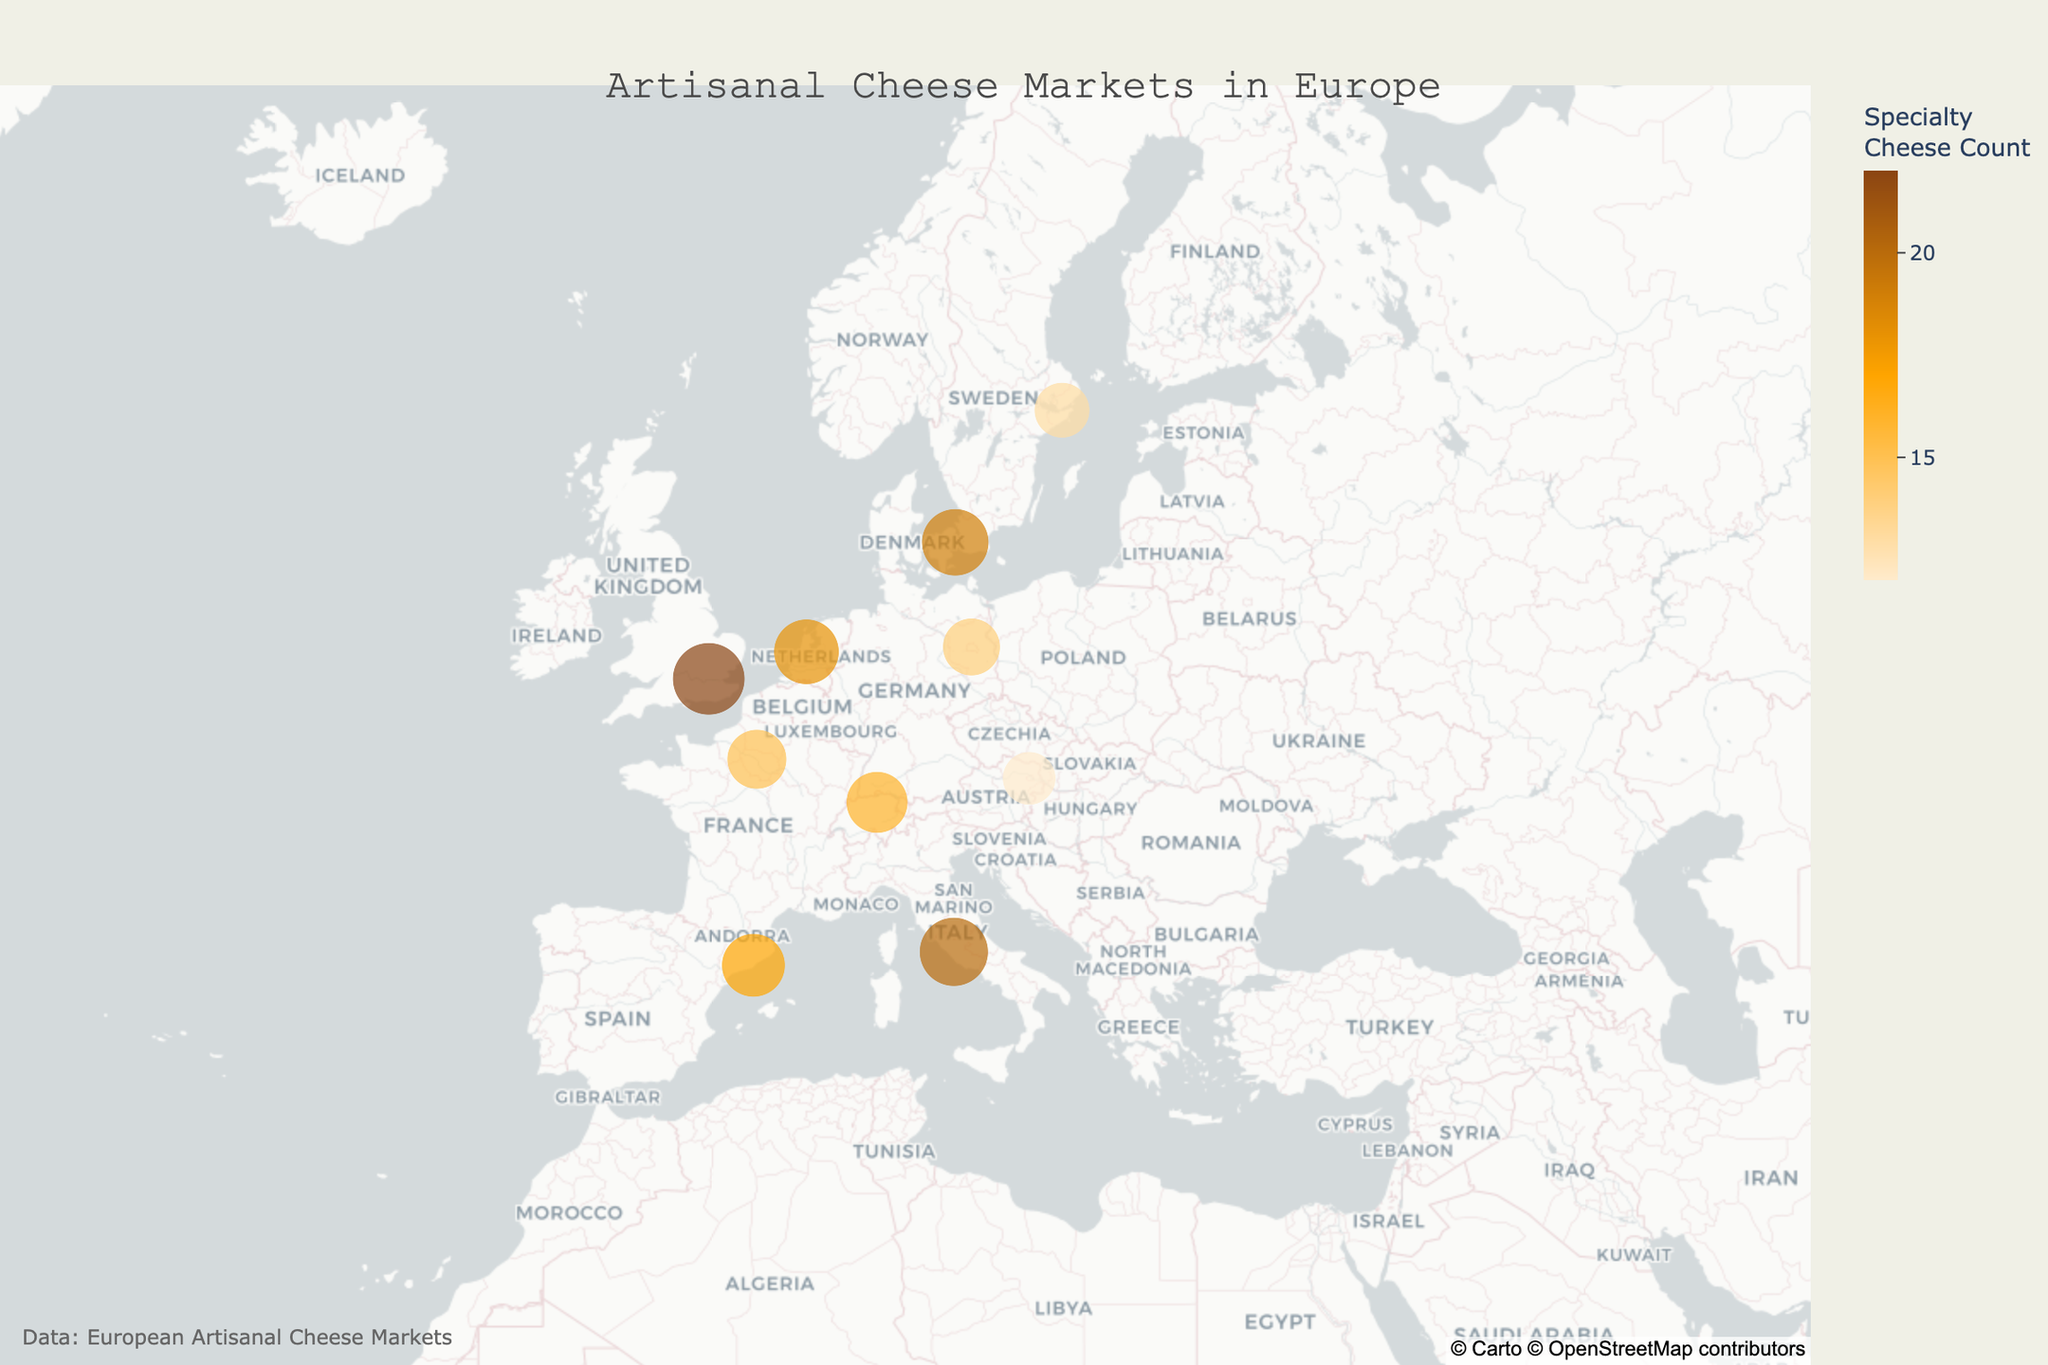What is the title of the map? The title is usually found at the top of the figure. In this map, it is positioned at the center and reads "Artisanal Cheese Markets in Europe".
Answer: Artisanal Cheese Markets in Europe Which city has the highest count of specialty cheeses, and how many does it have? To find this, look for the largest circle on the map, which corresponds to the market with the highest specialty cheese count. Upon inspecting the largest circles, we see that London (Borough Market) has the highest count.
Answer: London, 22 What is the average number of specialty cheeses available across all listed markets? Sum the counts of specialty cheeses from all data points, then divide by the total number of markets: (15 + 22 + 18 + 20 + 17 + 14 + 19 + 16 + 13 + 12) / 10 = 166 / 10 = 16.6
Answer: 16.6 Which market is situated farthest north, and what is its specialty cheese count? Look at the latitude values on the map or visually identify the topmost point on the map. The farthest north city displayed is Stockholm (Östermalms Saluhall).
Answer: Östermalms Saluhall, 13 How many markets have more than 18 different specialty cheeses? Analyze the size and color intensity of the circles. The markets with more than 18 cheeses are Borough Market (22), Albert Cuyp Market (18), Campo de' Fiori Market (20), and Torvehallerne (19), which sums up to 4 markets.
Answer: 4 Which country is represented multiple times in the data set, and what are the names of the markets it contains? Scan for city names within the same country. France, UK, Netherlands, Italy, Spain, Germany, Denmark, Switzerland, Sweden, and Austria are each only represented once. There are no countries with multiple representations.
Answer: None Which markets are located closest to each other geographically based on the map? Examine the proximity of the circles on the map. Paris (Marché Bastille) and Zurich (Viadukt Markthalle) appear relatively close, but Barcelona (La Boqueria Market) and Rome (Campo de' Fiori Market) are closer. They are in neighboring countries.
Answer: La Boqueria Market and Campo de' Fiori Market What are the approximate coordinates for the center of the map? The map's center is given in the map's initial settings. Here it is centered around latitude 50 and longitude 10.
Answer: Latitude 50, Longitude 10 Which market has the fewest specialty cheeses, and in which city is it located? Identify the smallest circle on the map. The smallest circle corresponds to Naschmarkt in Vienna.
Answer: Naschmarkt, Vienna 